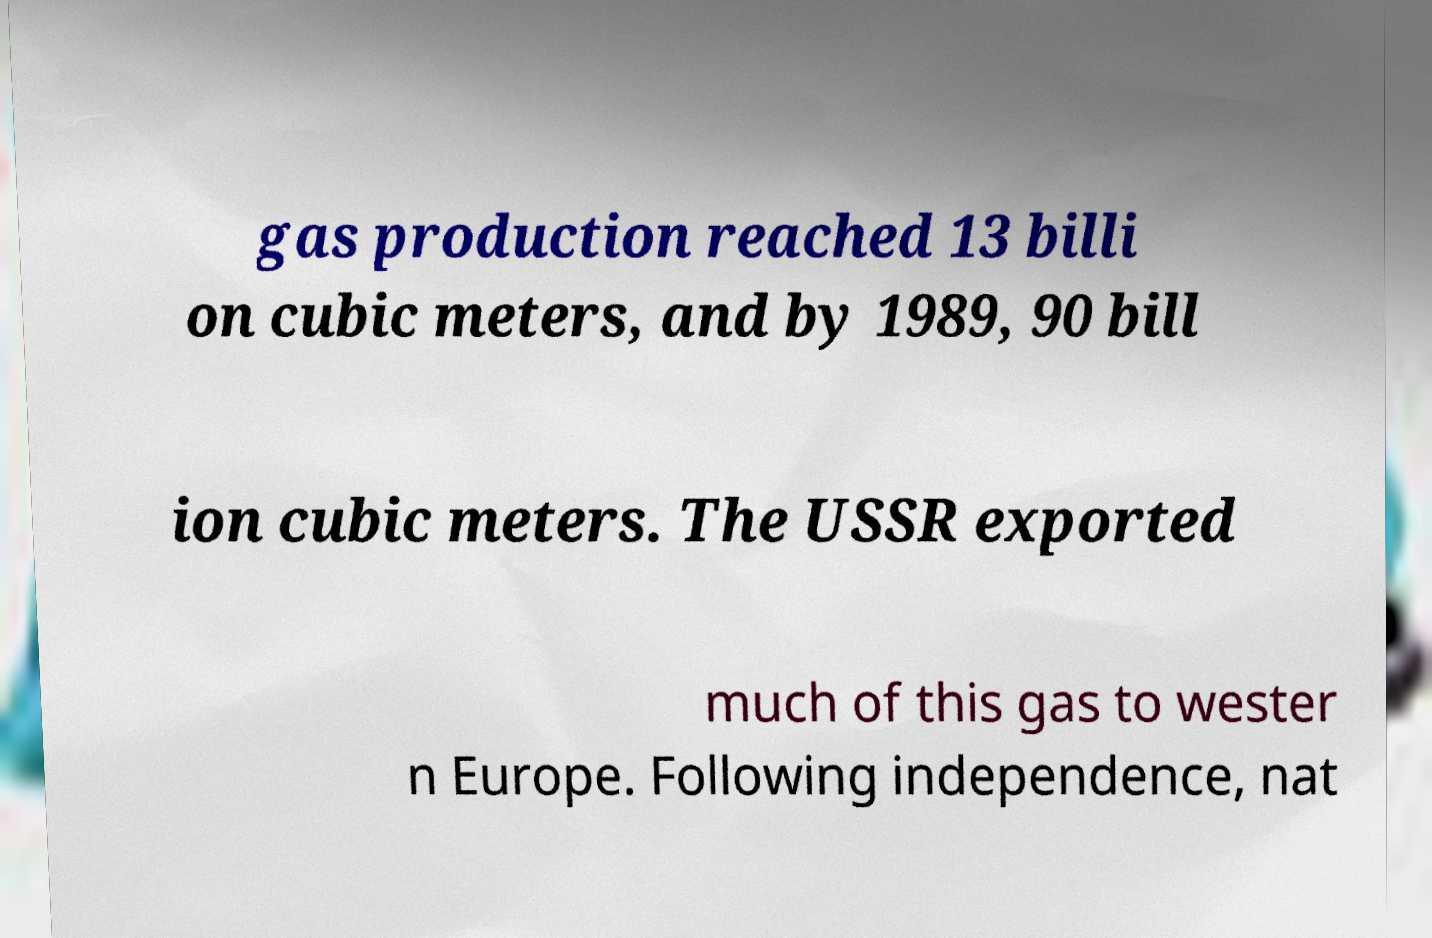Please read and relay the text visible in this image. What does it say? gas production reached 13 billi on cubic meters, and by 1989, 90 bill ion cubic meters. The USSR exported much of this gas to wester n Europe. Following independence, nat 